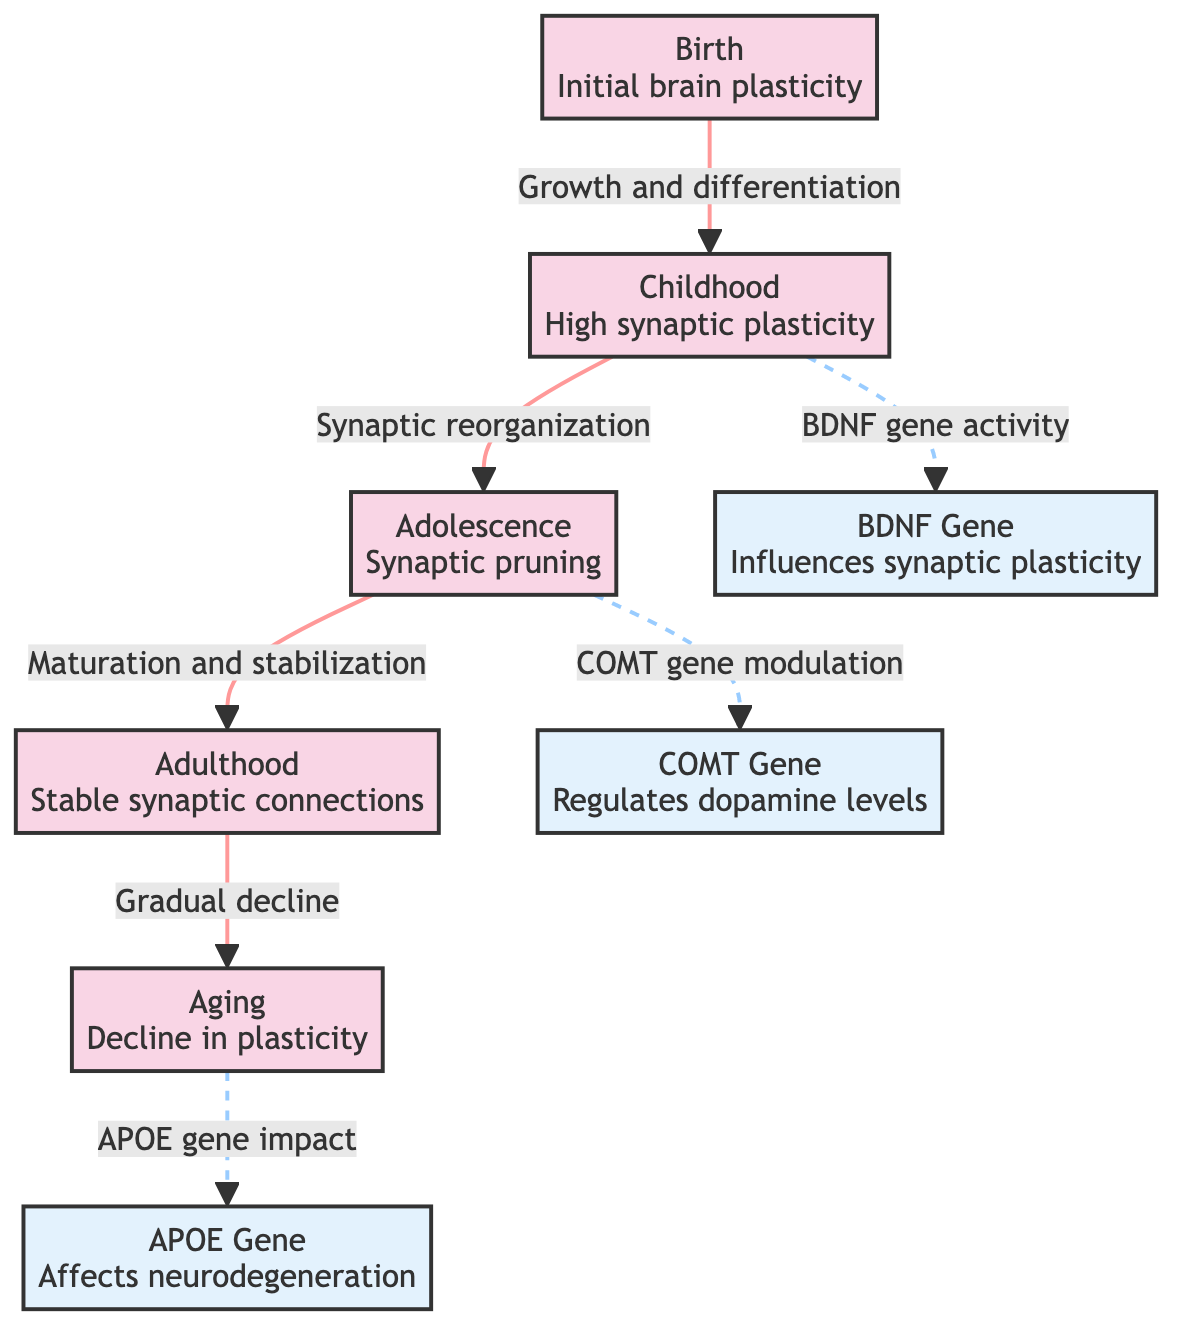What is the initial brain plasticity stage? The diagram indicates the "Birth" node as the starting point for initial brain plasticity. This is the first event listed, depicting the earliest stage of neuroplastic changes.
Answer: Birth How many genetic factors are identified in the diagram? The diagram shows a total of three genetic factors: BDNF Gene, COMT Gene, and APOE Gene. These are specifically categorized under genetic factors in the diagram.
Answer: 3 What is the main change occurring during Adolescence? According to the diagram, the primary change during Adolescence is "Synaptic pruning," which follows the high synaptic plasticity in Childhood and leads to the maturation and stabilization in Adulthood.
Answer: Synaptic pruning Which gene influences synaptic plasticity? The diagram designates the BDNF Gene as the genetic factor that influences synaptic plasticity, capturing the relationship between genetic factors and neuroplastic changes.
Answer: BDNF Gene What happens to synaptic connections in Adulthood? The diagram states that in Adulthood, there is a "Stable synaptic connections" stage, which indicates no further significant changes compared to earlier stages of development.
Answer: Stable synaptic connections How does Aging affect plasticity according to the diagram? The diagram illustrates that Aging leads to a "Decline in plasticity," indicating the reduction of neuroplastic capacity as one ages.
Answer: Decline in plasticity What kind of relationship connects Childhood and Adolescence? The diagram describes a direct relationship labeled "Synaptic reorganization," indicating a progression from high synaptic plasticity in Childhood to Synaptic pruning in Adolescence.
Answer: Synaptic reorganization Which genetic factor is associated with neurodegeneration? The diagram points to the APOE Gene as the genetic factor that affects neurodegeneration, illustrating its connection to the decline in plasticity during aging.
Answer: APOE Gene What connection is indicated between Adolescence and the COMT Gene? The diagram shows a dashed connection from Adolescence to the COMT Gene labeled as "COMT gene modulation," suggesting that genetic modulation occurs at this developmental stage.
Answer: COMT gene modulation 